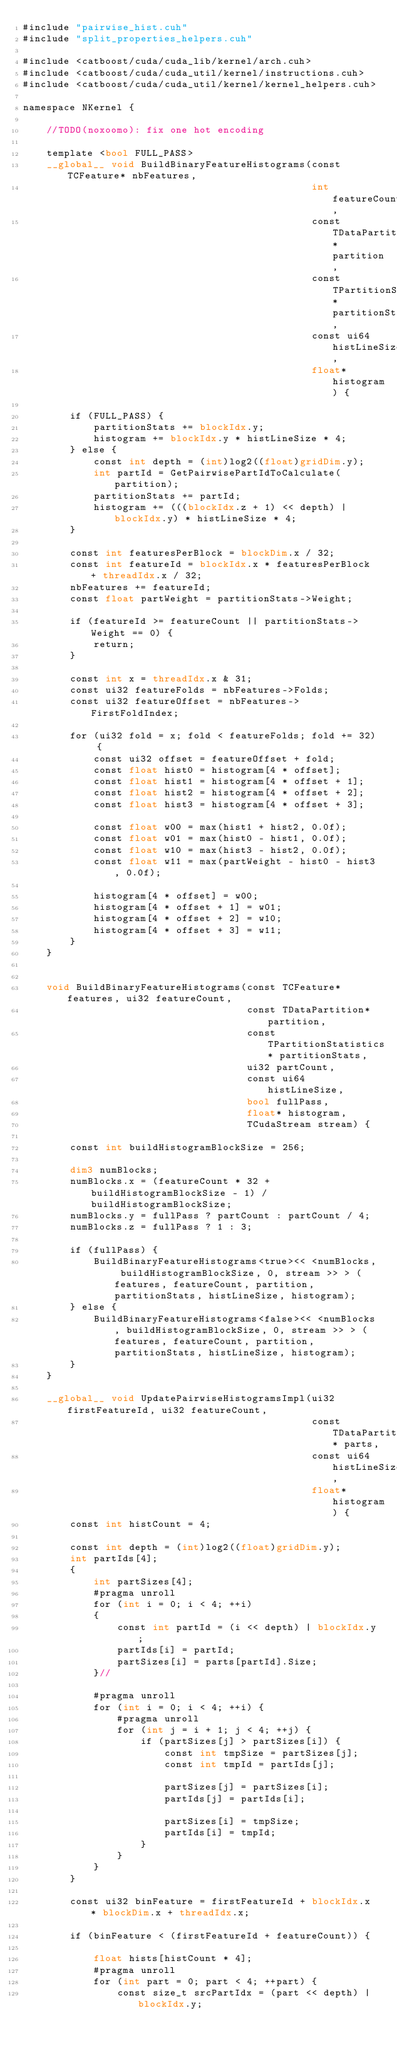Convert code to text. <code><loc_0><loc_0><loc_500><loc_500><_Cuda_>#include "pairwise_hist.cuh"
#include "split_properties_helpers.cuh"

#include <catboost/cuda/cuda_lib/kernel/arch.cuh>
#include <catboost/cuda/cuda_util/kernel/instructions.cuh>
#include <catboost/cuda/cuda_util/kernel/kernel_helpers.cuh>

namespace NKernel {

    //TODO(noxoomo): fix one hot encoding

    template <bool FULL_PASS>
    __global__ void BuildBinaryFeatureHistograms(const TCFeature* nbFeatures,
                                                 int featureCount,
                                                 const TDataPartition* partition,
                                                 const TPartitionStatistics* partitionStats,
                                                 const ui64 histLineSize,
                                                 float* histogram) {

        if (FULL_PASS) {
            partitionStats += blockIdx.y;
            histogram += blockIdx.y * histLineSize * 4;
        } else {
            const int depth = (int)log2((float)gridDim.y);
            int partId = GetPairwisePartIdToCalculate(partition);
            partitionStats += partId;
            histogram += (((blockIdx.z + 1) << depth) | blockIdx.y) * histLineSize * 4;
        }

        const int featuresPerBlock = blockDim.x / 32;
        const int featureId = blockIdx.x * featuresPerBlock + threadIdx.x / 32;
        nbFeatures += featureId;
        const float partWeight = partitionStats->Weight;

        if (featureId >= featureCount || partitionStats->Weight == 0) {
            return;
        }

        const int x = threadIdx.x & 31;
        const ui32 featureFolds = nbFeatures->Folds;
        const ui32 featureOffset = nbFeatures->FirstFoldIndex;

        for (ui32 fold = x; fold < featureFolds; fold += 32) {
            const ui32 offset = featureOffset + fold;
            const float hist0 = histogram[4 * offset];
            const float hist1 = histogram[4 * offset + 1];
            const float hist2 = histogram[4 * offset + 2];
            const float hist3 = histogram[4 * offset + 3];

            const float w00 = max(hist1 + hist2, 0.0f);
            const float w01 = max(hist0 - hist1, 0.0f);
            const float w10 = max(hist3 - hist2, 0.0f);
            const float w11 = max(partWeight - hist0 - hist3, 0.0f);

            histogram[4 * offset] = w00;
            histogram[4 * offset + 1] = w01;
            histogram[4 * offset + 2] = w10;
            histogram[4 * offset + 3] = w11;
        }
    }


    void BuildBinaryFeatureHistograms(const TCFeature* features, ui32 featureCount,
                                      const TDataPartition* partition,
                                      const TPartitionStatistics* partitionStats,
                                      ui32 partCount,
                                      const ui64 histLineSize,
                                      bool fullPass,
                                      float* histogram,
                                      TCudaStream stream) {

        const int buildHistogramBlockSize = 256;

        dim3 numBlocks;
        numBlocks.x = (featureCount * 32 + buildHistogramBlockSize - 1) / buildHistogramBlockSize;
        numBlocks.y = fullPass ? partCount : partCount / 4;
        numBlocks.z = fullPass ? 1 : 3;

        if (fullPass) {
            BuildBinaryFeatureHistograms<true><< <numBlocks, buildHistogramBlockSize, 0, stream >> > (features, featureCount, partition, partitionStats, histLineSize, histogram);
        } else {
            BuildBinaryFeatureHistograms<false><< <numBlocks, buildHistogramBlockSize, 0, stream >> > (features, featureCount, partition, partitionStats, histLineSize, histogram);
        }
    }

    __global__ void UpdatePairwiseHistogramsImpl(ui32 firstFeatureId, ui32 featureCount,
                                                 const TDataPartition* parts,
                                                 const ui64 histLineSize,
                                                 float* histogram) {
        const int histCount = 4;

        const int depth = (int)log2((float)gridDim.y);
        int partIds[4];
        {
            int partSizes[4];
            #pragma unroll
            for (int i = 0; i < 4; ++i)
            {
                const int partId = (i << depth) | blockIdx.y;
                partIds[i] = partId;
                partSizes[i] = parts[partId].Size;
            }//

            #pragma unroll
            for (int i = 0; i < 4; ++i) {
                #pragma unroll
                for (int j = i + 1; j < 4; ++j) {
                    if (partSizes[j] > partSizes[i]) {
                        const int tmpSize = partSizes[j];
                        const int tmpId = partIds[j];

                        partSizes[j] = partSizes[i];
                        partIds[j] = partIds[i];

                        partSizes[i] = tmpSize;
                        partIds[i] = tmpId;
                    }
                }
            }
        }

        const ui32 binFeature = firstFeatureId + blockIdx.x * blockDim.x + threadIdx.x;

        if (binFeature < (firstFeatureId + featureCount)) {

            float hists[histCount * 4];
            #pragma unroll
            for (int part = 0; part < 4; ++part) {
                const size_t srcPartIdx = (part << depth) | blockIdx.y;
</code> 